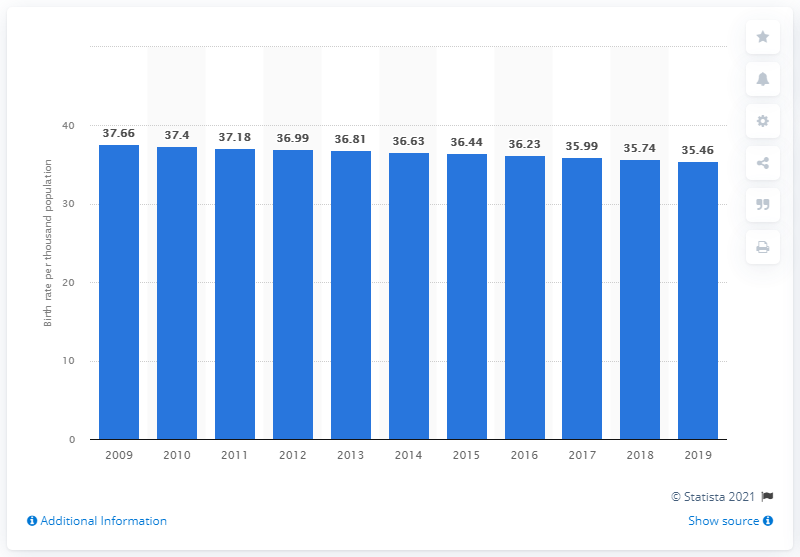Give some essential details in this illustration. The crude birth rate in Côte d'Ivoire in 2019 was 35.46. 